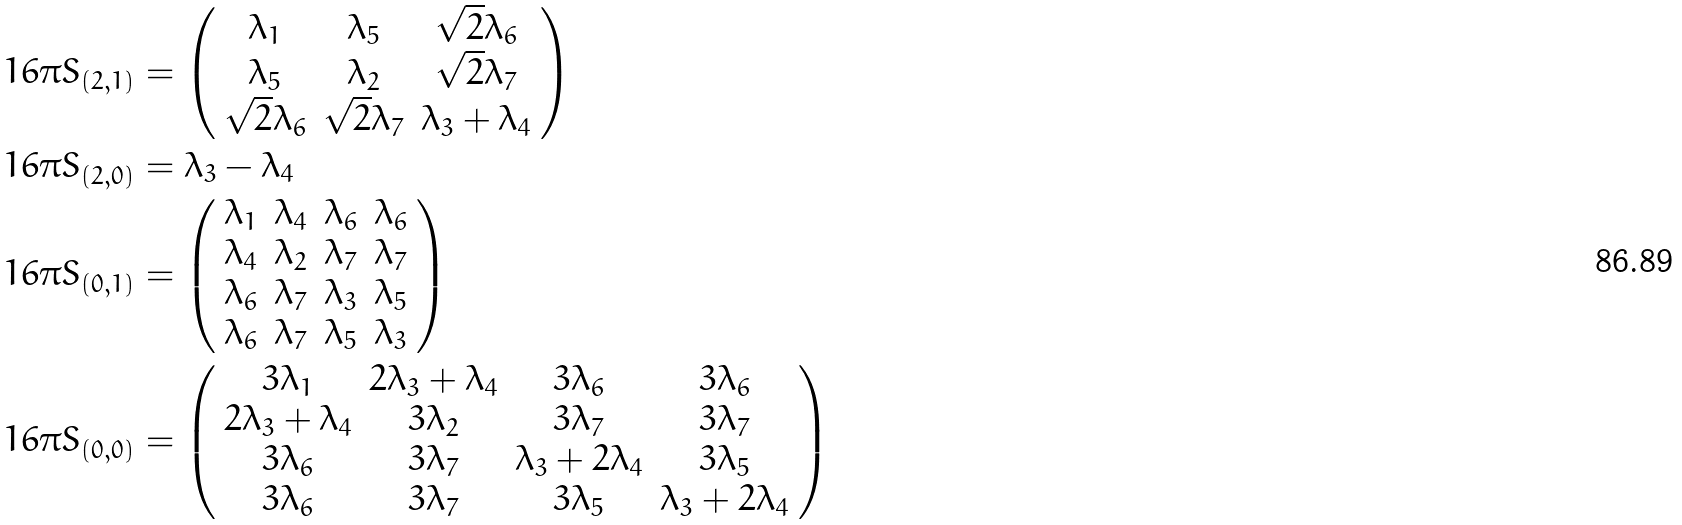<formula> <loc_0><loc_0><loc_500><loc_500>1 6 \pi S _ { ( 2 , 1 ) } & = \left ( \begin{array} { c c c } \lambda _ { 1 } & \lambda _ { 5 } & \sqrt { 2 } \lambda _ { 6 } \\ \lambda _ { 5 } & \lambda _ { 2 } & \sqrt { 2 } \lambda _ { 7 } \\ \sqrt { 2 } \lambda _ { 6 } & \sqrt { 2 } \lambda _ { 7 } & \lambda _ { 3 } + \lambda _ { 4 } \end{array} \right ) \\ 1 6 \pi S _ { ( 2 , 0 ) } & = \lambda _ { 3 } - \lambda _ { 4 } \\ 1 6 \pi S _ { ( 0 , 1 ) } & = \left ( \begin{array} { c c c c } \lambda _ { 1 } & \lambda _ { 4 } & \lambda _ { 6 } & \lambda _ { 6 } \\ \lambda _ { 4 } & \lambda _ { 2 } & \lambda _ { 7 } & \lambda _ { 7 } \\ \lambda _ { 6 } & \lambda _ { 7 } & \lambda _ { 3 } & \lambda _ { 5 } \\ \lambda _ { 6 } & \lambda _ { 7 } & \lambda _ { 5 } & \lambda _ { 3 } \end{array} \right ) \\ 1 6 \pi S _ { ( 0 , 0 ) } & = \left ( \begin{array} { c c c c } 3 \lambda _ { 1 } & 2 \lambda _ { 3 } + \lambda _ { 4 } & 3 \lambda _ { 6 } & 3 \lambda _ { 6 } \\ 2 \lambda _ { 3 } + \lambda _ { 4 } & 3 \lambda _ { 2 } & 3 \lambda _ { 7 } & 3 \lambda _ { 7 } \\ 3 \lambda _ { 6 } & 3 \lambda _ { 7 } & \lambda _ { 3 } + 2 \lambda _ { 4 } & 3 \lambda _ { 5 } \\ 3 \lambda _ { 6 } & 3 \lambda _ { 7 } & 3 \lambda _ { 5 } & \lambda _ { 3 } + 2 \lambda _ { 4 } \end{array} \right )</formula> 